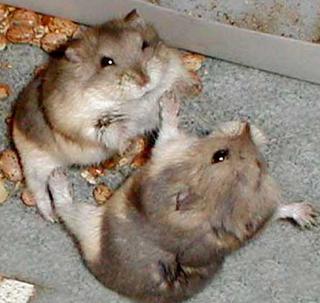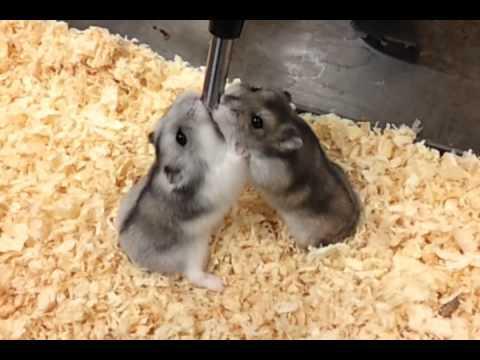The first image is the image on the left, the second image is the image on the right. Analyze the images presented: Is the assertion "There are in total three hamsters in the images." valid? Answer yes or no. No. The first image is the image on the left, the second image is the image on the right. For the images shown, is this caption "There is one pair of brown and white hamsters fighting with each other in the image on the left." true? Answer yes or no. Yes. 